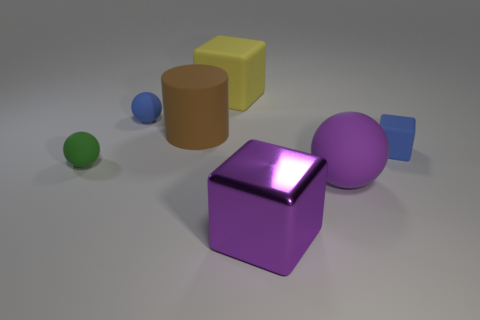What is the color of the rubber block on the right side of the yellow matte block?
Your answer should be very brief. Blue. The green sphere has what size?
Your answer should be compact. Small. There is a tiny matte cube; is it the same color as the matte sphere on the right side of the large purple shiny cube?
Keep it short and to the point. No. What is the color of the big block in front of the blue matte object that is right of the yellow thing?
Your answer should be compact. Purple. Are there any other things that have the same size as the brown cylinder?
Ensure brevity in your answer.  Yes. Do the small blue thing that is right of the big purple rubber sphere and the green object have the same shape?
Offer a very short reply. No. What number of objects are on the right side of the small green thing and in front of the blue cube?
Keep it short and to the point. 2. What color is the rubber cube on the right side of the large matte thing that is to the right of the rubber cube that is behind the brown matte cylinder?
Your answer should be very brief. Blue. How many big purple blocks are on the right side of the big matte object on the right side of the large metal block?
Offer a terse response. 0. How many other things are there of the same shape as the brown object?
Provide a short and direct response. 0. 